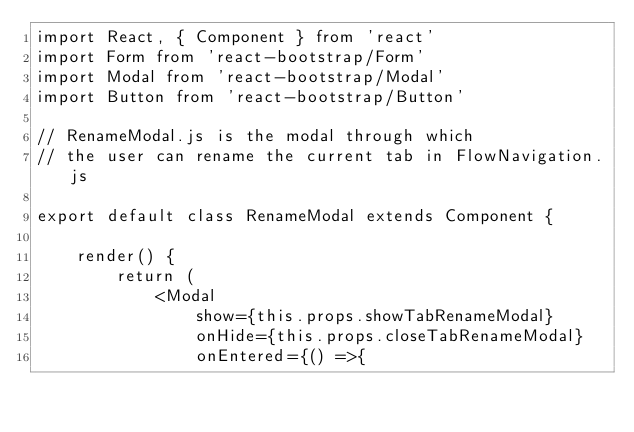Convert code to text. <code><loc_0><loc_0><loc_500><loc_500><_JavaScript_>import React, { Component } from 'react'
import Form from 'react-bootstrap/Form'
import Modal from 'react-bootstrap/Modal'
import Button from 'react-bootstrap/Button'

// RenameModal.js is the modal through which
// the user can rename the current tab in FlowNavigation.js

export default class RenameModal extends Component {

    render() {
        return (
            <Modal
                show={this.props.showTabRenameModal}
                onHide={this.props.closeTabRenameModal}
                onEntered={() =>{</code> 